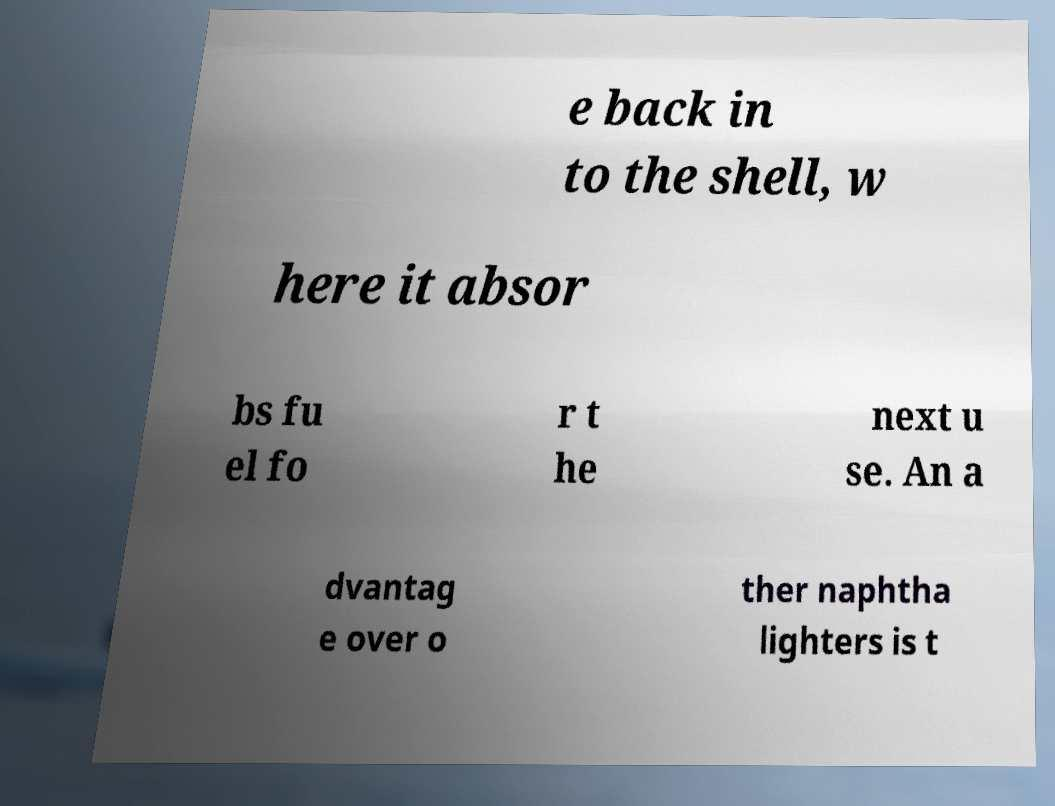Can you read and provide the text displayed in the image?This photo seems to have some interesting text. Can you extract and type it out for me? e back in to the shell, w here it absor bs fu el fo r t he next u se. An a dvantag e over o ther naphtha lighters is t 